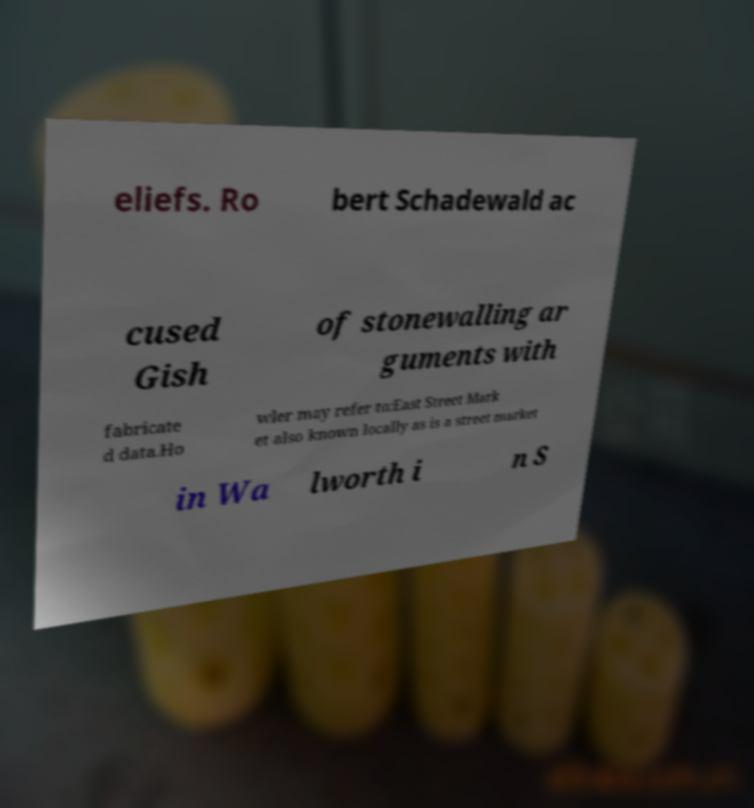Please read and relay the text visible in this image. What does it say? eliefs. Ro bert Schadewald ac cused Gish of stonewalling ar guments with fabricate d data.Ho wler may refer to:East Street Mark et also known locally as is a street market in Wa lworth i n S 